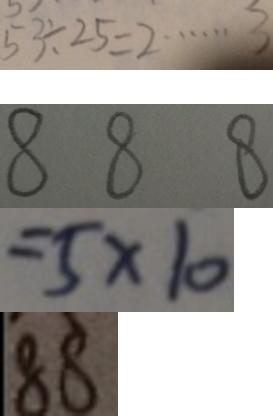Convert formula to latex. <formula><loc_0><loc_0><loc_500><loc_500>5 3 \div 2 5 = 2 \cdots 3 
 8 8 8 
 = 5 \times 1 0 
 8 8</formula> 